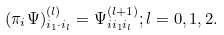Convert formula to latex. <formula><loc_0><loc_0><loc_500><loc_500>( \pi _ { i } \Psi ) _ { i _ { 1 } \cdot i _ { l } } ^ { ( l ) } = \Psi _ { i i _ { 1 } i _ { l } } ^ { ( l + 1 ) } ; l = 0 , 1 , 2 .</formula> 